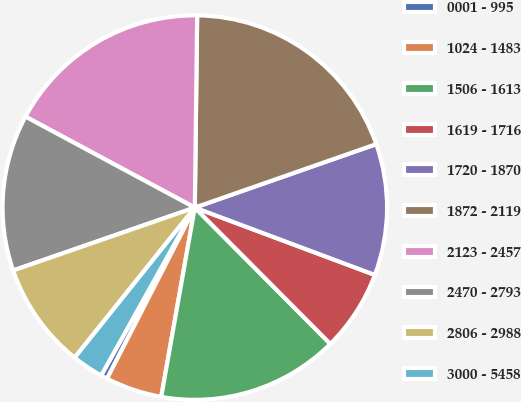Convert chart to OTSL. <chart><loc_0><loc_0><loc_500><loc_500><pie_chart><fcel>0001 - 995<fcel>1024 - 1483<fcel>1506 - 1613<fcel>1619 - 1716<fcel>1720 - 1870<fcel>1872 - 2119<fcel>2123 - 2457<fcel>2470 - 2793<fcel>2806 - 2988<fcel>3000 - 5458<nl><fcel>0.55%<fcel>4.75%<fcel>15.25%<fcel>6.85%<fcel>11.05%<fcel>19.45%<fcel>17.35%<fcel>13.15%<fcel>8.95%<fcel>2.65%<nl></chart> 